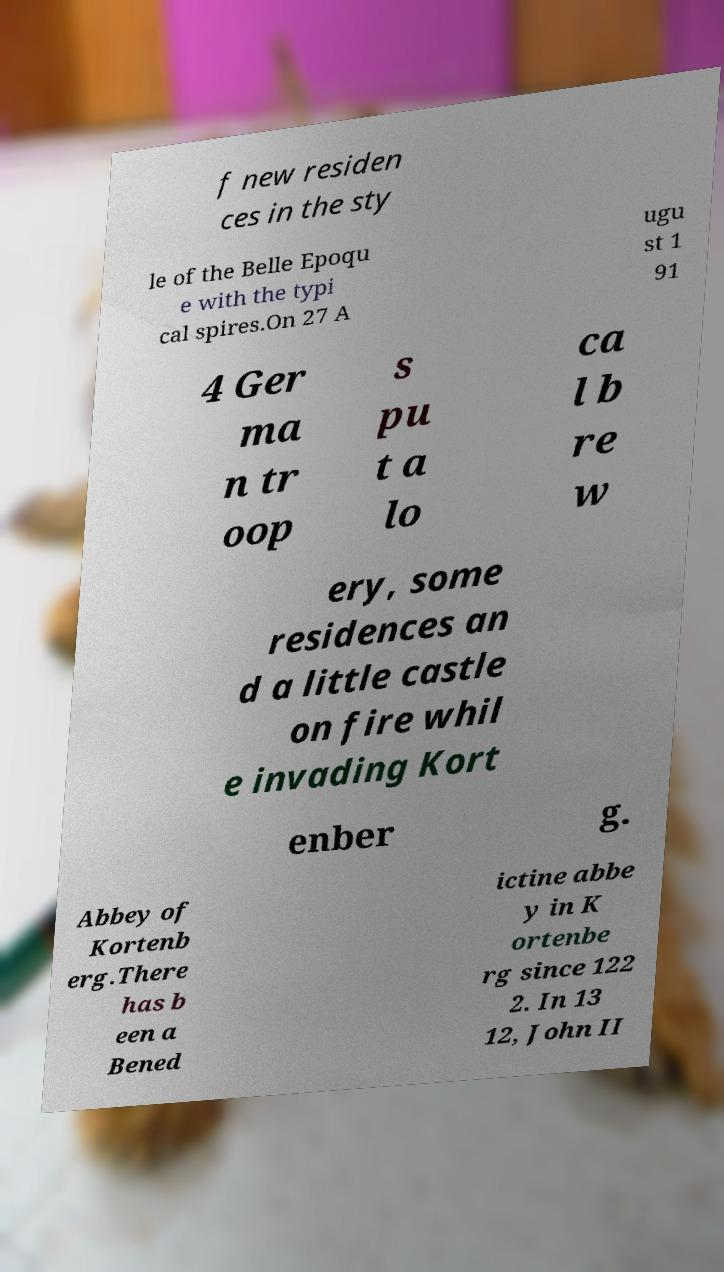Could you extract and type out the text from this image? f new residen ces in the sty le of the Belle Epoqu e with the typi cal spires.On 27 A ugu st 1 91 4 Ger ma n tr oop s pu t a lo ca l b re w ery, some residences an d a little castle on fire whil e invading Kort enber g. Abbey of Kortenb erg.There has b een a Bened ictine abbe y in K ortenbe rg since 122 2. In 13 12, John II 